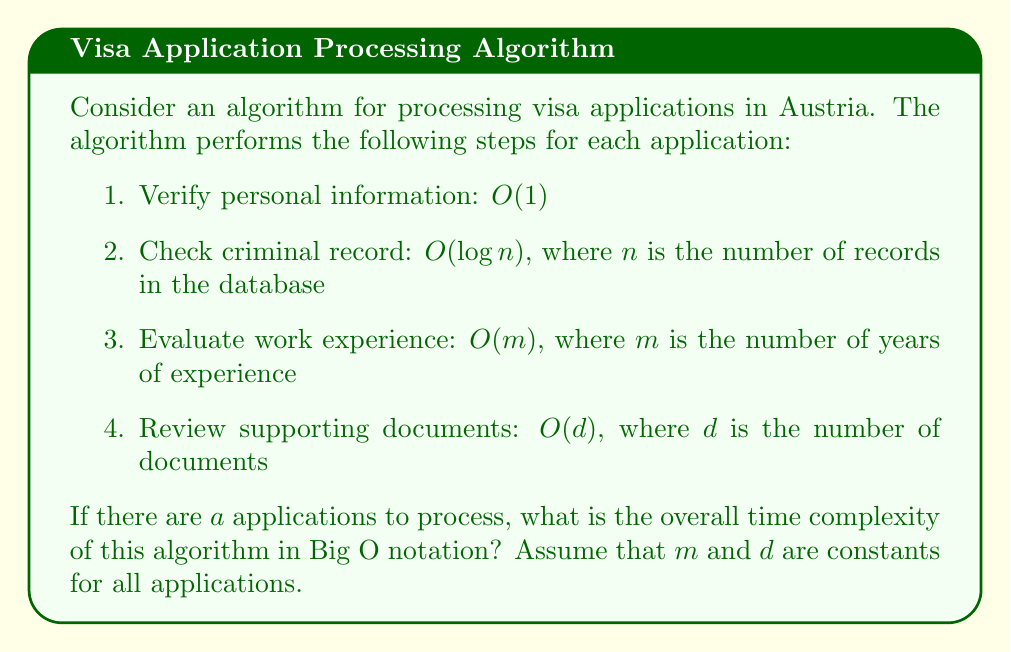Provide a solution to this math problem. Let's analyze the time complexity step by step:

1. For each application, we perform four operations:
   - Verify personal information: $O(1)$
   - Check criminal record: $O(\log n)$
   - Evaluate work experience: $O(m)$
   - Review supporting documents: $O(d)$

2. The time complexity for processing a single application is the sum of these operations:
   $O(1) + O(\log n) + O(m) + O(d)$

3. Since $m$ and $d$ are constants, we can simplify this to:
   $O(1) + O(\log n) + O(1) + O(1) = O(\log n)$

4. We process $a$ applications, so we multiply the complexity of a single application by $a$:
   $a \cdot O(\log n) = O(a \log n)$

Therefore, the overall time complexity of the algorithm is $O(a \log n)$, where $a$ is the number of applications and $n$ is the size of the criminal record database.
Answer: $O(a \log n)$ 